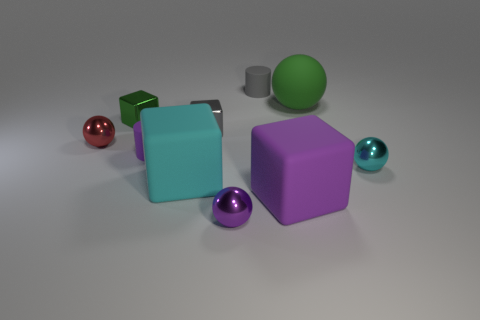Subtract all large balls. How many balls are left? 3 Subtract all blocks. How many objects are left? 6 Subtract 1 cylinders. How many cylinders are left? 1 Add 2 small cyan metallic spheres. How many small cyan metallic spheres exist? 3 Subtract all gray cylinders. How many cylinders are left? 1 Subtract 0 blue balls. How many objects are left? 10 Subtract all purple cubes. Subtract all red balls. How many cubes are left? 3 Subtract all gray cylinders. How many gray blocks are left? 1 Subtract all brown metal spheres. Subtract all large cyan matte objects. How many objects are left? 9 Add 5 small spheres. How many small spheres are left? 8 